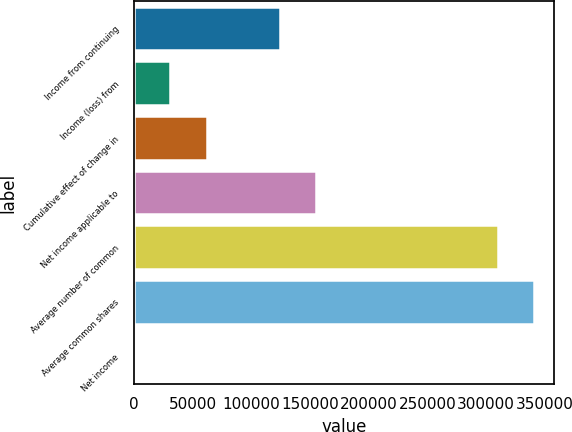<chart> <loc_0><loc_0><loc_500><loc_500><bar_chart><fcel>Income from continuing<fcel>Income (loss) from<fcel>Cumulative effect of change in<fcel>Net income applicable to<fcel>Average number of common<fcel>Average common shares<fcel>Net income<nl><fcel>123918<fcel>30980.7<fcel>61959.7<fcel>154897<fcel>309792<fcel>340771<fcel>1.66<nl></chart> 